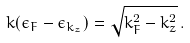<formula> <loc_0><loc_0><loc_500><loc_500>k ( \epsilon _ { F } - \epsilon _ { k _ { z } } ) = \sqrt { k _ { F } ^ { 2 } - k _ { z } ^ { 2 } } \, .</formula> 